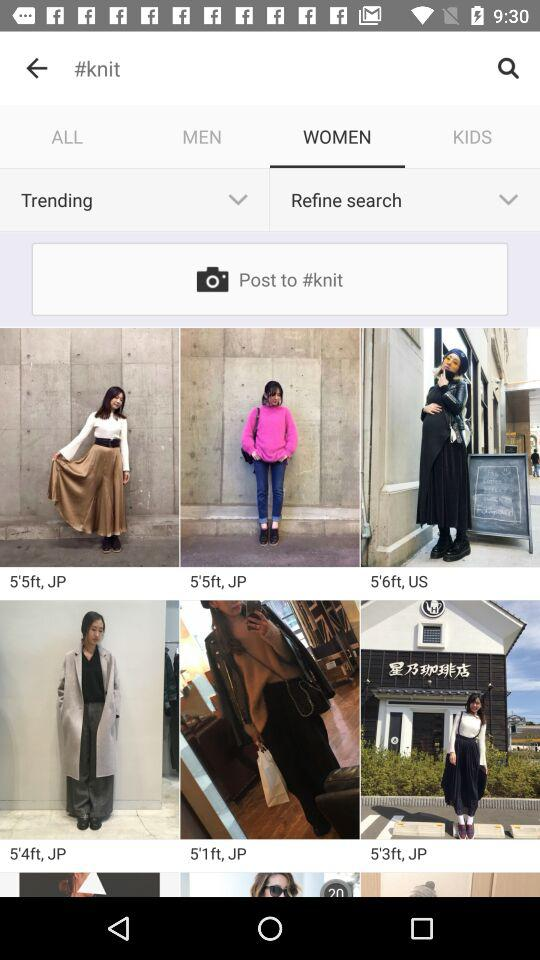What is the selected tab? The selected tab is "WOMEN". 